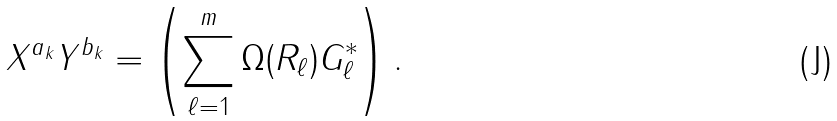Convert formula to latex. <formula><loc_0><loc_0><loc_500><loc_500>X ^ { a _ { k } } Y ^ { b _ { k } } = \left ( \sum _ { \ell = 1 } ^ { m } \Omega ( R _ { \ell } ) G ^ { * } _ { \ell } \right ) .</formula> 